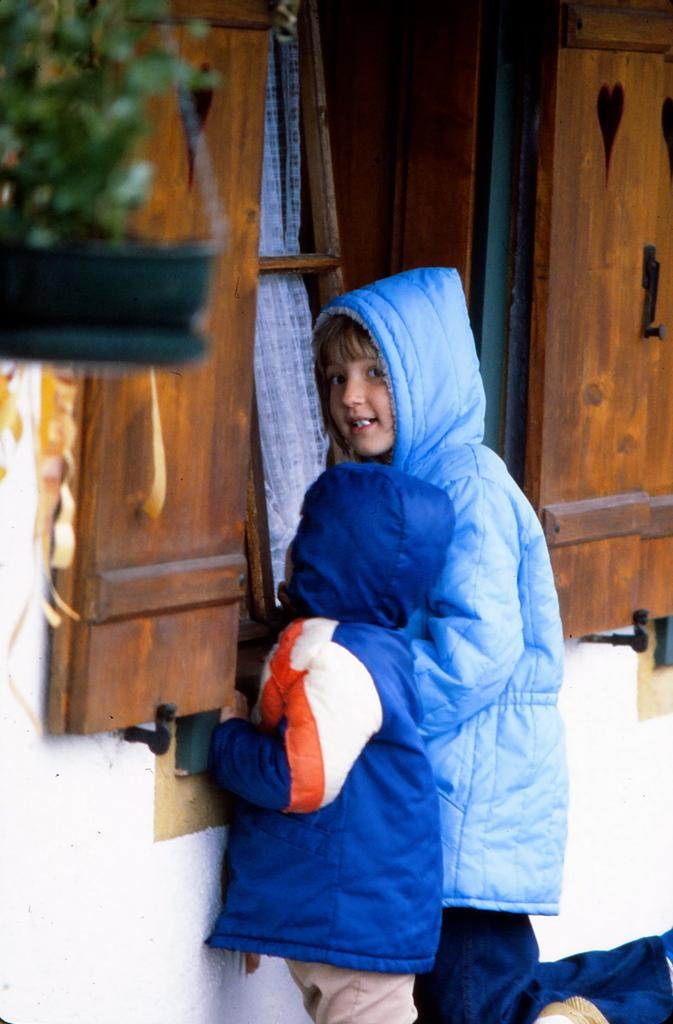Who is present in the image? There are kids in the image. What are the kids wearing? The kids are wearing jackets. What can be seen in the background of the image? There is a wall, a wooden window, and a curtain in the image. What is located near the window? There is a flower pot in the image. What type of office equipment can be seen in the image? There is no office equipment present in the image. How many tickets are visible in the image? There are no tickets visible in the image. 